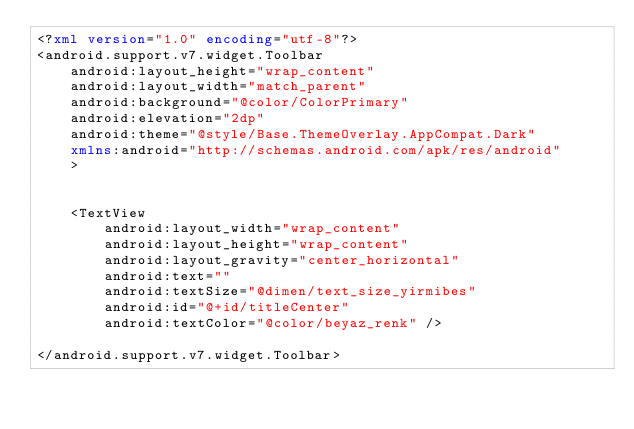<code> <loc_0><loc_0><loc_500><loc_500><_XML_><?xml version="1.0" encoding="utf-8"?>
<android.support.v7.widget.Toolbar
    android:layout_height="wrap_content"
    android:layout_width="match_parent"
    android:background="@color/ColorPrimary"
    android:elevation="2dp"
    android:theme="@style/Base.ThemeOverlay.AppCompat.Dark"
    xmlns:android="http://schemas.android.com/apk/res/android"
    >


    <TextView
        android:layout_width="wrap_content"
        android:layout_height="wrap_content"
        android:layout_gravity="center_horizontal"
        android:text=""
        android:textSize="@dimen/text_size_yirmibes"
        android:id="@+id/titleCenter"
        android:textColor="@color/beyaz_renk" />

</android.support.v7.widget.Toolbar></code> 